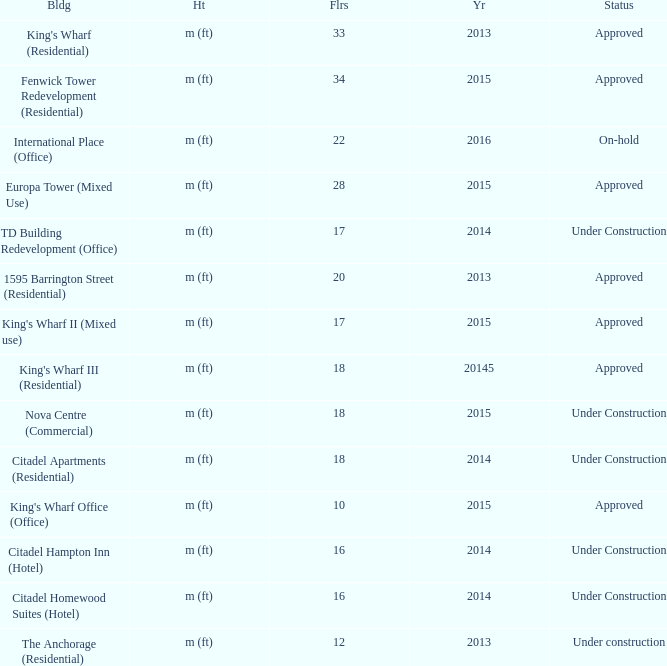What is the status of the building for 2014 with 33 floors? Approved. 